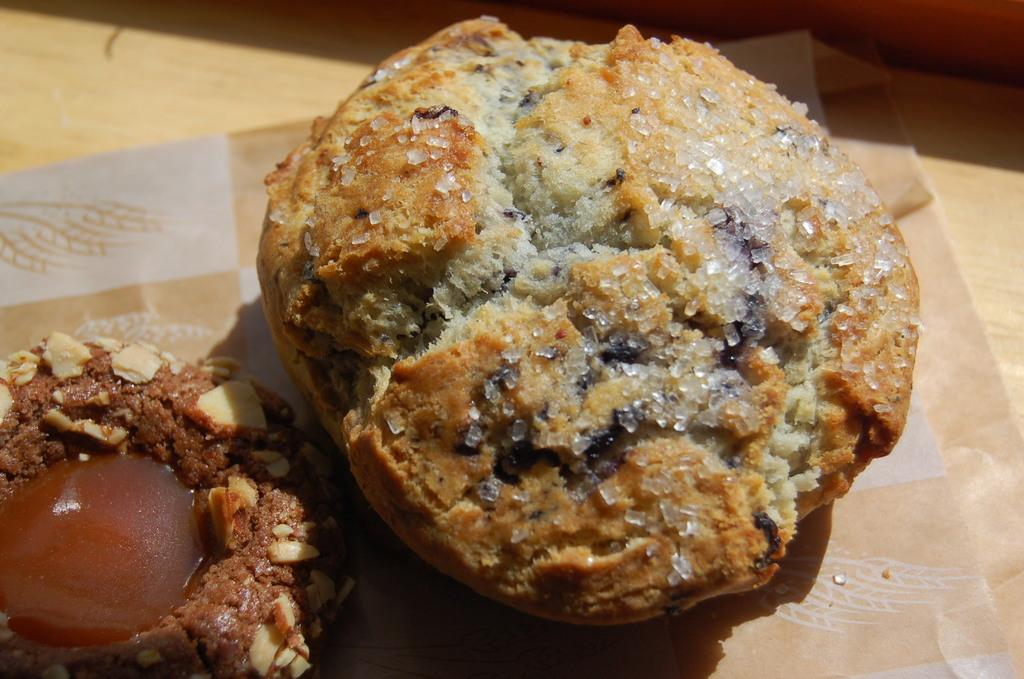What is present on the paper in the image? There are two cookies on the paper in the image. What type of surface is visible in the background of the image? There is a wooden surface visible in the background of the image. What type of hammer is Aunt Sally using in the image? There is no hammer or Aunt Sally present in the image; it only features two cookies on a paper. 